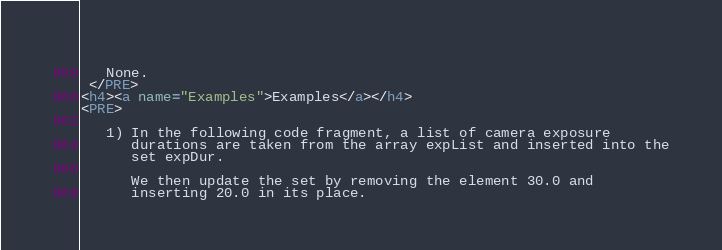Convert code to text. <code><loc_0><loc_0><loc_500><loc_500><_HTML_> 
   None. 
 </PRE>
<h4><a name="Examples">Examples</a></h4>
<PRE>
 
   1) In the following code fragment, a list of camera exposure
      durations are taken from the array expList and inserted into the
      set expDur.

      We then update the set by removing the element 30.0 and 
      inserting 20.0 in its place.

</code> 